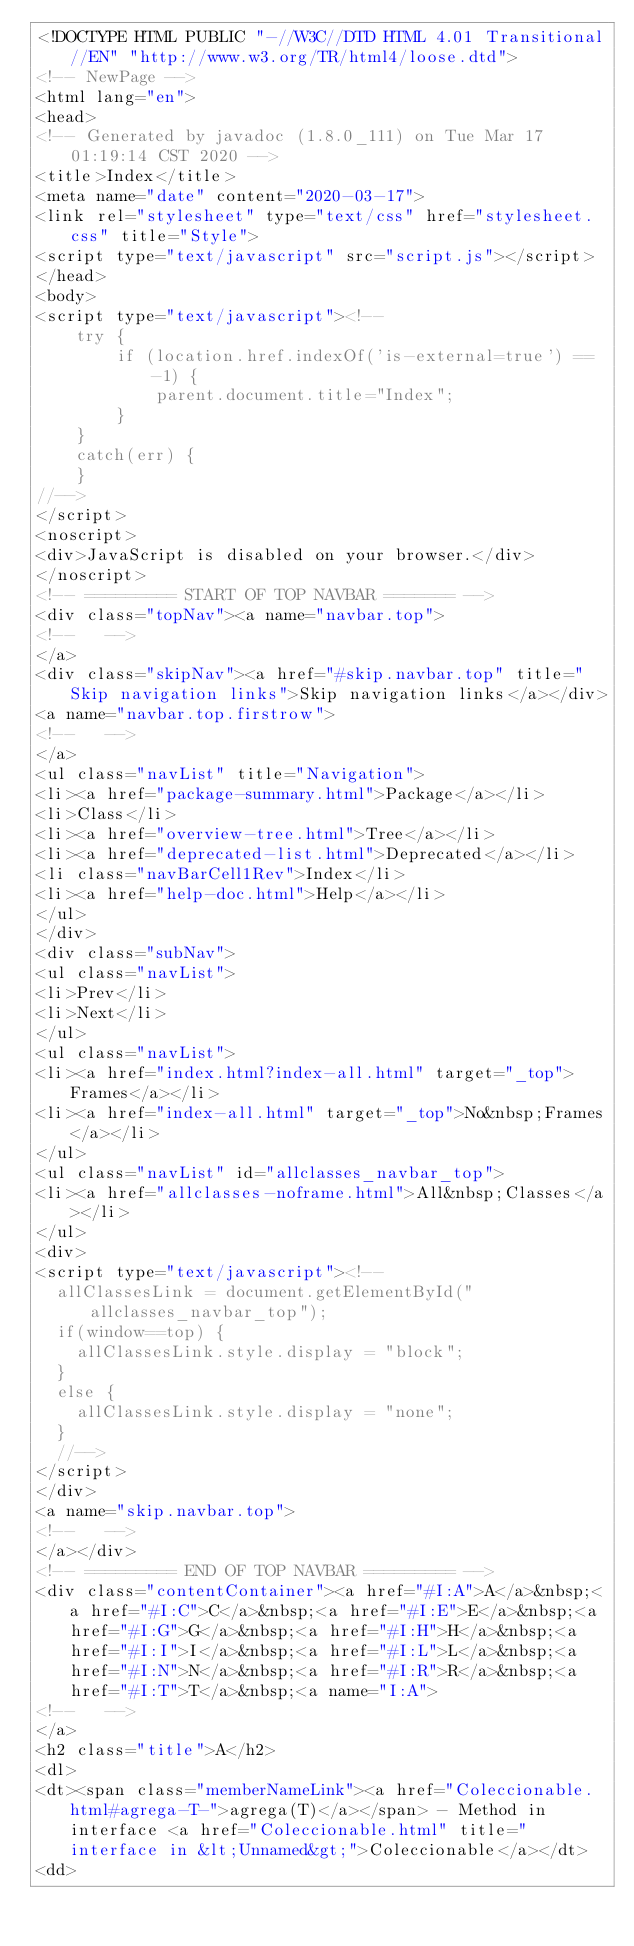<code> <loc_0><loc_0><loc_500><loc_500><_HTML_><!DOCTYPE HTML PUBLIC "-//W3C//DTD HTML 4.01 Transitional//EN" "http://www.w3.org/TR/html4/loose.dtd">
<!-- NewPage -->
<html lang="en">
<head>
<!-- Generated by javadoc (1.8.0_111) on Tue Mar 17 01:19:14 CST 2020 -->
<title>Index</title>
<meta name="date" content="2020-03-17">
<link rel="stylesheet" type="text/css" href="stylesheet.css" title="Style">
<script type="text/javascript" src="script.js"></script>
</head>
<body>
<script type="text/javascript"><!--
    try {
        if (location.href.indexOf('is-external=true') == -1) {
            parent.document.title="Index";
        }
    }
    catch(err) {
    }
//-->
</script>
<noscript>
<div>JavaScript is disabled on your browser.</div>
</noscript>
<!-- ========= START OF TOP NAVBAR ======= -->
<div class="topNav"><a name="navbar.top">
<!--   -->
</a>
<div class="skipNav"><a href="#skip.navbar.top" title="Skip navigation links">Skip navigation links</a></div>
<a name="navbar.top.firstrow">
<!--   -->
</a>
<ul class="navList" title="Navigation">
<li><a href="package-summary.html">Package</a></li>
<li>Class</li>
<li><a href="overview-tree.html">Tree</a></li>
<li><a href="deprecated-list.html">Deprecated</a></li>
<li class="navBarCell1Rev">Index</li>
<li><a href="help-doc.html">Help</a></li>
</ul>
</div>
<div class="subNav">
<ul class="navList">
<li>Prev</li>
<li>Next</li>
</ul>
<ul class="navList">
<li><a href="index.html?index-all.html" target="_top">Frames</a></li>
<li><a href="index-all.html" target="_top">No&nbsp;Frames</a></li>
</ul>
<ul class="navList" id="allclasses_navbar_top">
<li><a href="allclasses-noframe.html">All&nbsp;Classes</a></li>
</ul>
<div>
<script type="text/javascript"><!--
  allClassesLink = document.getElementById("allclasses_navbar_top");
  if(window==top) {
    allClassesLink.style.display = "block";
  }
  else {
    allClassesLink.style.display = "none";
  }
  //-->
</script>
</div>
<a name="skip.navbar.top">
<!--   -->
</a></div>
<!-- ========= END OF TOP NAVBAR ========= -->
<div class="contentContainer"><a href="#I:A">A</a>&nbsp;<a href="#I:C">C</a>&nbsp;<a href="#I:E">E</a>&nbsp;<a href="#I:G">G</a>&nbsp;<a href="#I:H">H</a>&nbsp;<a href="#I:I">I</a>&nbsp;<a href="#I:L">L</a>&nbsp;<a href="#I:N">N</a>&nbsp;<a href="#I:R">R</a>&nbsp;<a href="#I:T">T</a>&nbsp;<a name="I:A">
<!--   -->
</a>
<h2 class="title">A</h2>
<dl>
<dt><span class="memberNameLink"><a href="Coleccionable.html#agrega-T-">agrega(T)</a></span> - Method in interface <a href="Coleccionable.html" title="interface in &lt;Unnamed&gt;">Coleccionable</a></dt>
<dd></code> 